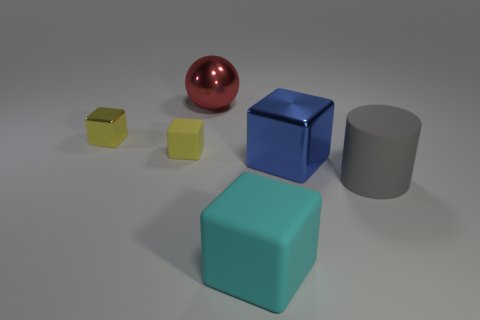Subtract all green balls. How many yellow blocks are left? 2 Subtract all yellow rubber cubes. How many cubes are left? 3 Add 3 brown metal cubes. How many objects exist? 9 Subtract all blue blocks. How many blocks are left? 3 Subtract all balls. How many objects are left? 5 Subtract 1 yellow blocks. How many objects are left? 5 Subtract all gray blocks. Subtract all brown cylinders. How many blocks are left? 4 Subtract all metal blocks. Subtract all large red balls. How many objects are left? 3 Add 1 metallic balls. How many metallic balls are left? 2 Add 5 small cubes. How many small cubes exist? 7 